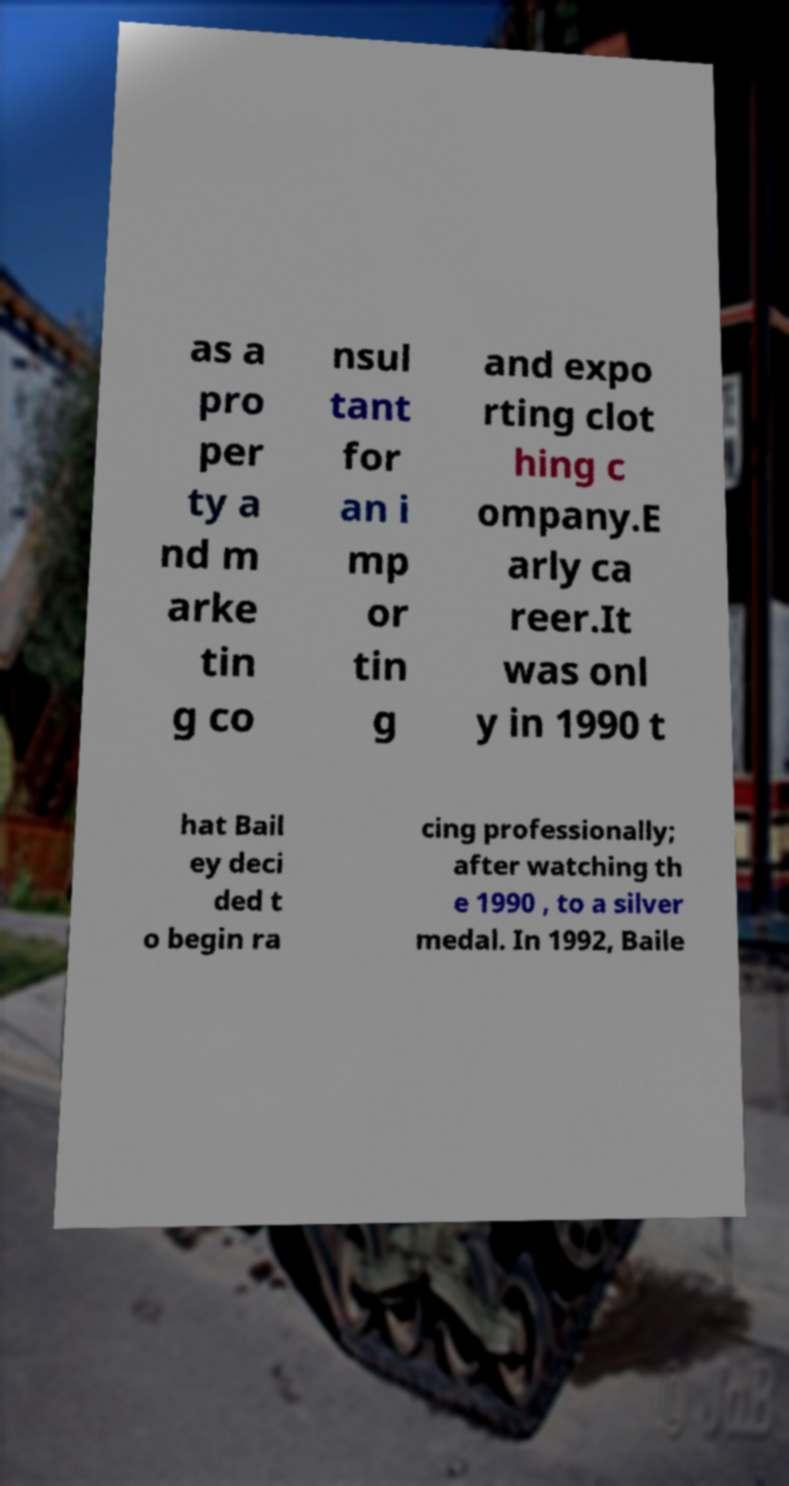There's text embedded in this image that I need extracted. Can you transcribe it verbatim? as a pro per ty a nd m arke tin g co nsul tant for an i mp or tin g and expo rting clot hing c ompany.E arly ca reer.It was onl y in 1990 t hat Bail ey deci ded t o begin ra cing professionally; after watching th e 1990 , to a silver medal. In 1992, Baile 